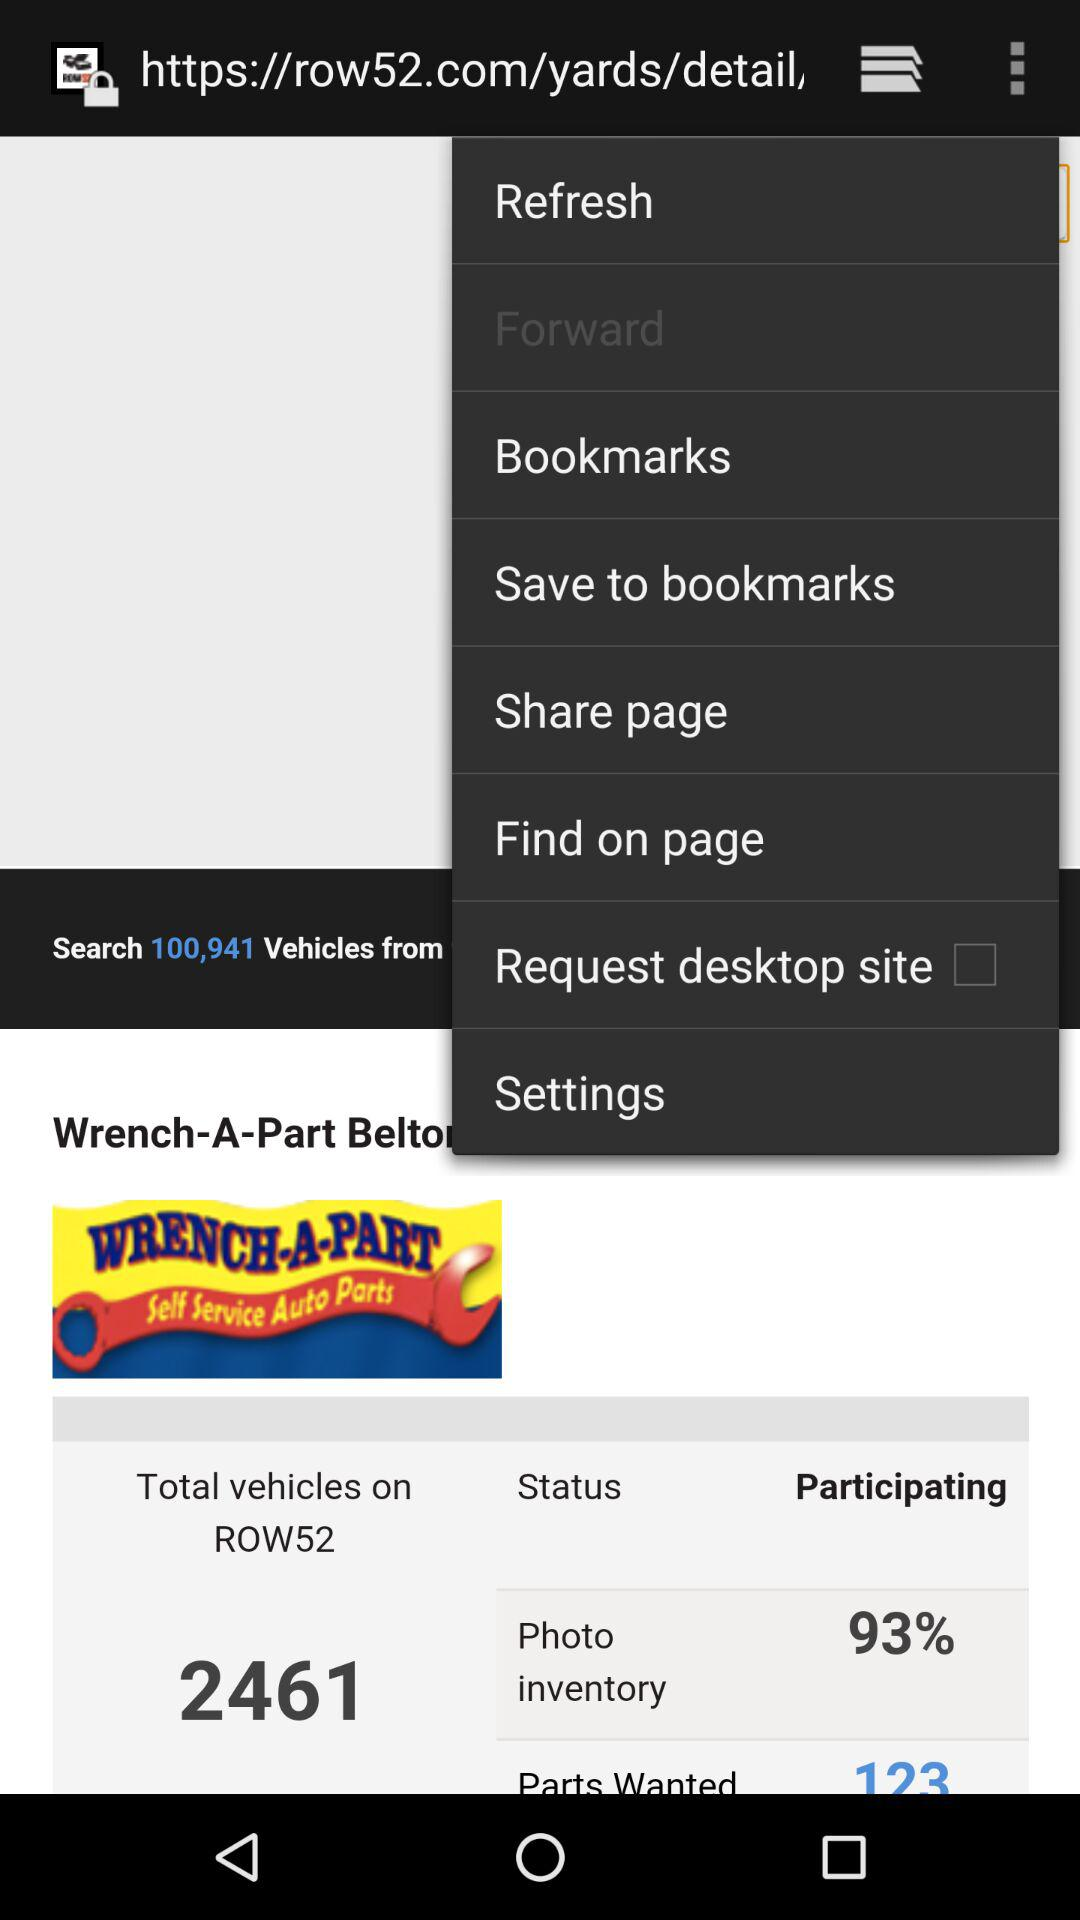What is the % of photo inventory? The % of photo inventory is 93. 